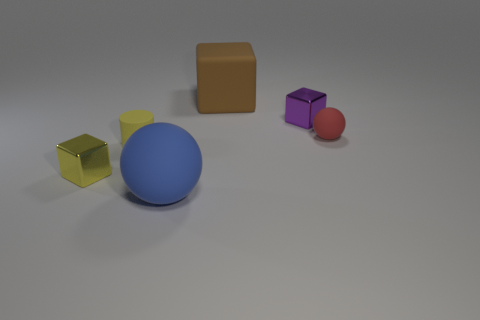Add 2 tiny red balls. How many objects exist? 8 Subtract all cylinders. How many objects are left? 5 Add 3 tiny metallic objects. How many tiny metallic objects are left? 5 Add 3 large blue spheres. How many large blue spheres exist? 4 Subtract 1 brown cubes. How many objects are left? 5 Subtract all small red metal objects. Subtract all tiny cubes. How many objects are left? 4 